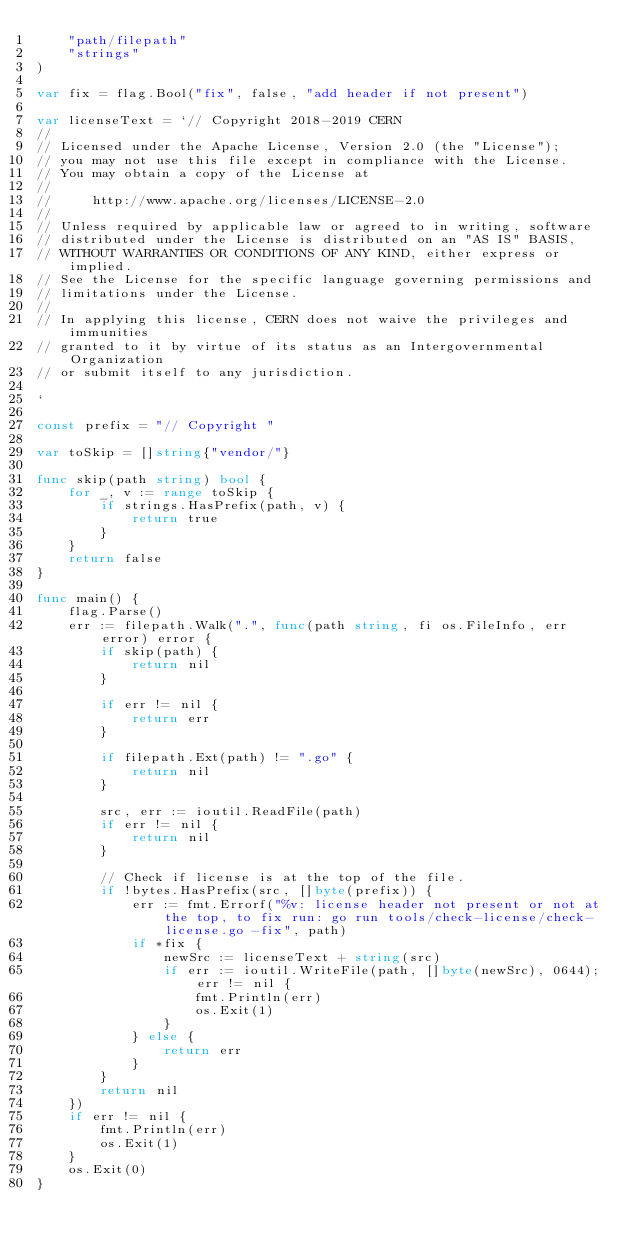Convert code to text. <code><loc_0><loc_0><loc_500><loc_500><_Go_>	"path/filepath"
	"strings"
)

var fix = flag.Bool("fix", false, "add header if not present")

var licenseText = `// Copyright 2018-2019 CERN
//
// Licensed under the Apache License, Version 2.0 (the "License");
// you may not use this file except in compliance with the License.
// You may obtain a copy of the License at
//
//     http://www.apache.org/licenses/LICENSE-2.0
//
// Unless required by applicable law or agreed to in writing, software
// distributed under the License is distributed on an "AS IS" BASIS,
// WITHOUT WARRANTIES OR CONDITIONS OF ANY KIND, either express or implied.
// See the License for the specific language governing permissions and
// limitations under the License.
//
// In applying this license, CERN does not waive the privileges and immunities
// granted to it by virtue of its status as an Intergovernmental Organization
// or submit itself to any jurisdiction.

`

const prefix = "// Copyright "

var toSkip = []string{"vendor/"}

func skip(path string) bool {
	for _, v := range toSkip {
		if strings.HasPrefix(path, v) {
			return true
		}
	}
	return false
}

func main() {
	flag.Parse()
	err := filepath.Walk(".", func(path string, fi os.FileInfo, err error) error {
		if skip(path) {
			return nil
		}

		if err != nil {
			return err
		}

		if filepath.Ext(path) != ".go" {
			return nil
		}

		src, err := ioutil.ReadFile(path)
		if err != nil {
			return nil
		}

		// Check if license is at the top of the file.
		if !bytes.HasPrefix(src, []byte(prefix)) {
			err := fmt.Errorf("%v: license header not present or not at the top, to fix run: go run tools/check-license/check-license.go -fix", path)
			if *fix {
				newSrc := licenseText + string(src)
				if err := ioutil.WriteFile(path, []byte(newSrc), 0644); err != nil {
					fmt.Println(err)
					os.Exit(1)
				}
			} else {
				return err
			}
		}
		return nil
	})
	if err != nil {
		fmt.Println(err)
		os.Exit(1)
	}
	os.Exit(0)
}
</code> 